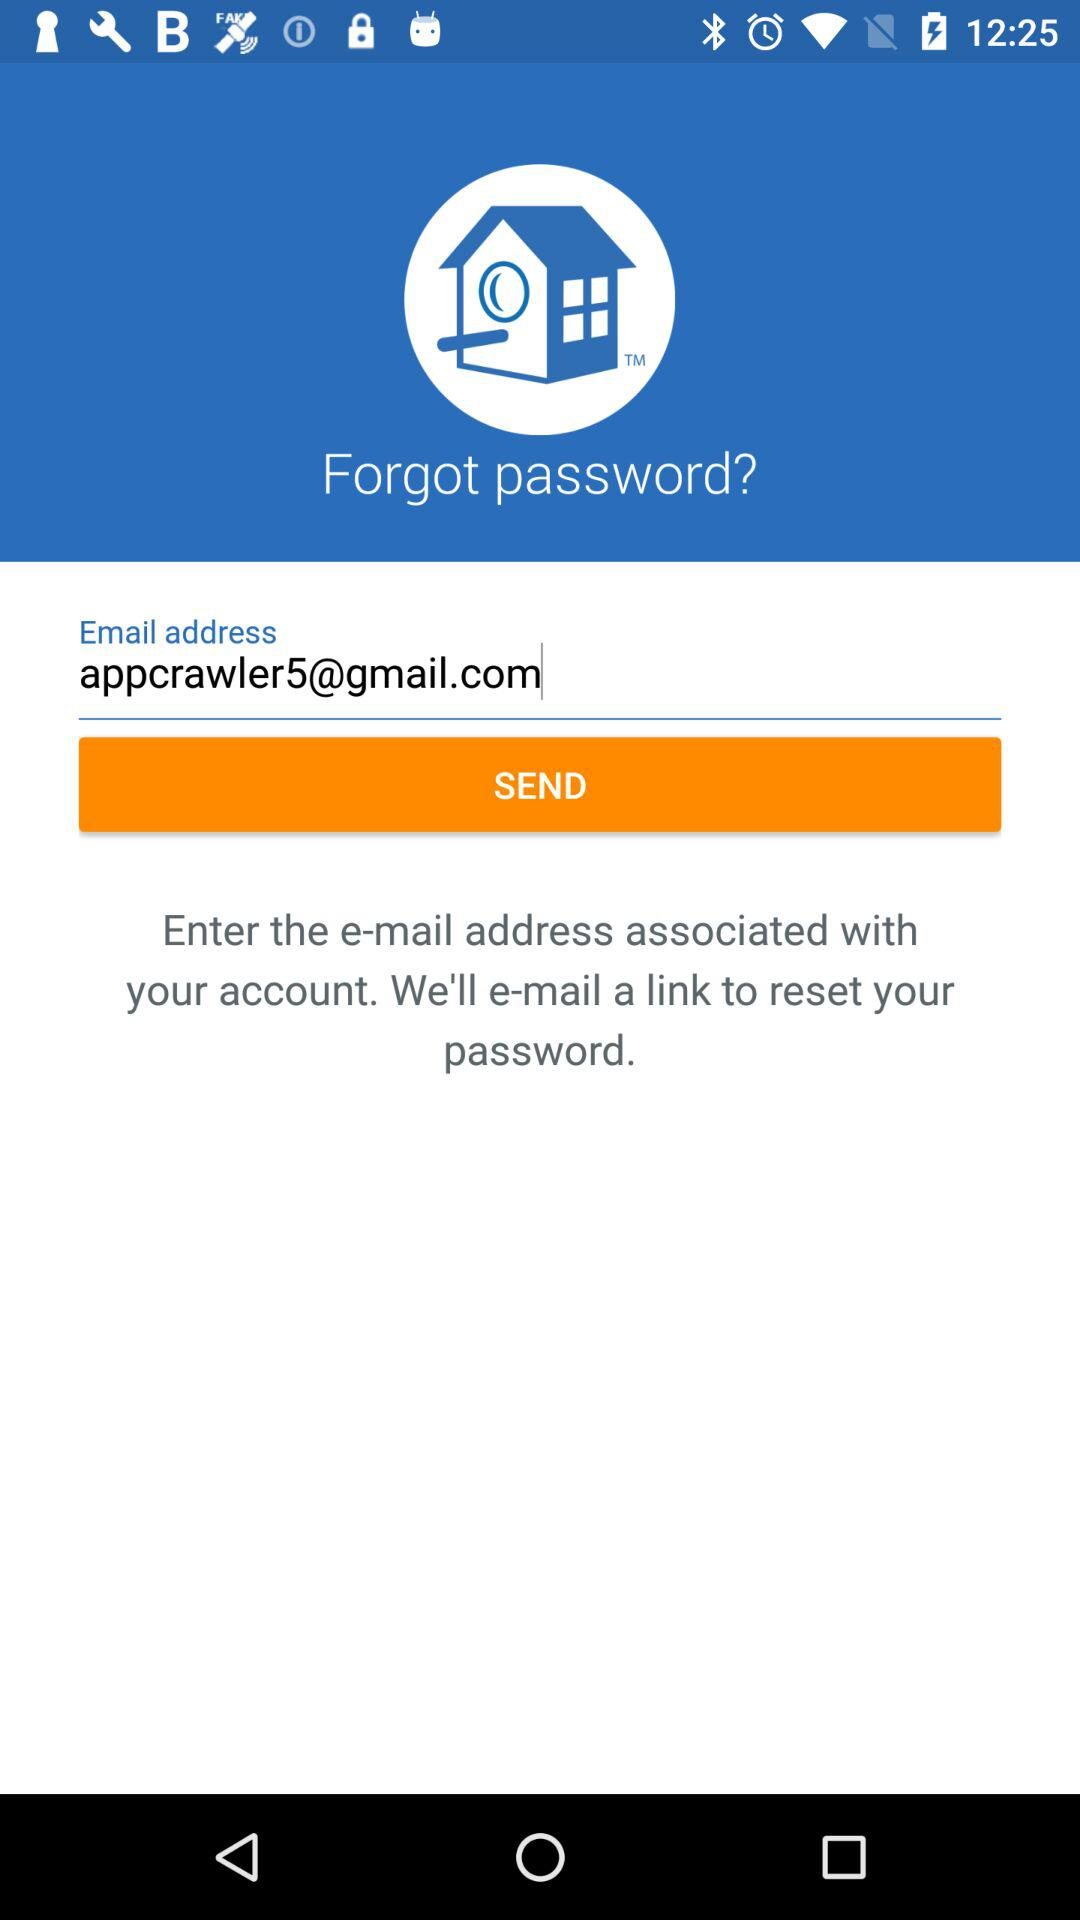What is the given email address? The given email address is appcrawler5@gmail.com. 